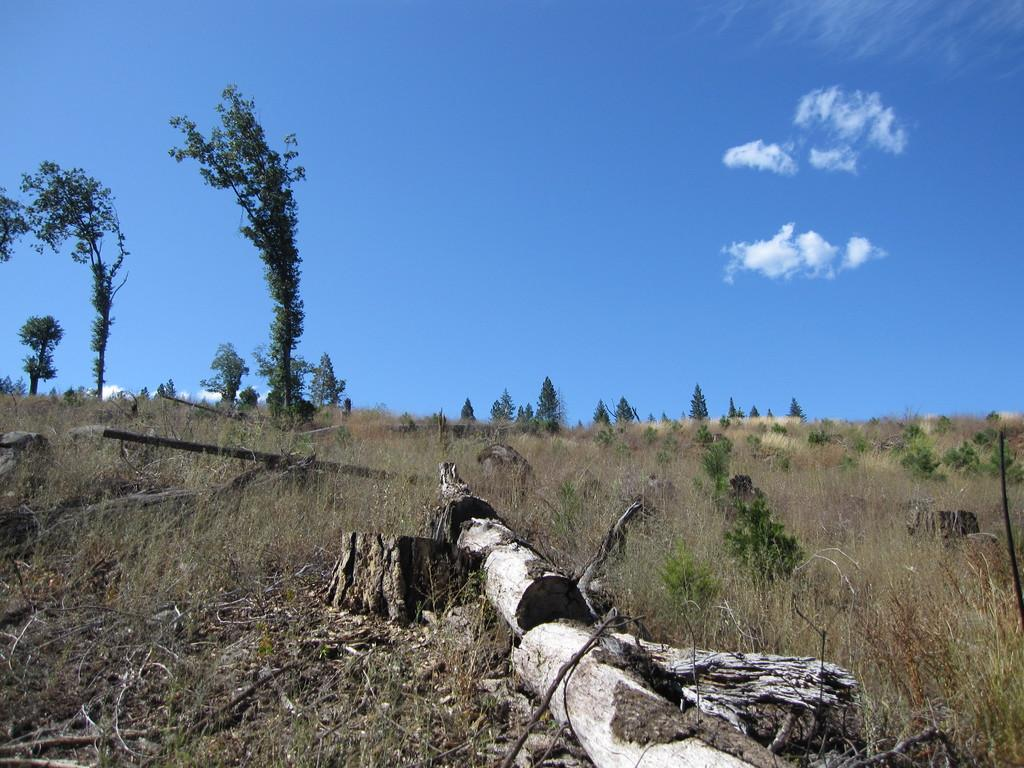What type of vegetation can be seen in the image? There are plants, grass, and trees in the image. What is the ground covered with in the image? The ground is covered with grass in the image. What can be seen in the sky in the image? The sky is blue and cloudy in the image. What part of a tree is visible in the image? Tree bark is visible in the image. What type of straw is being used to decorate the church in the image? There is no church or straw present in the image; it features plants, grass, trees, and a blue, cloudy sky. 